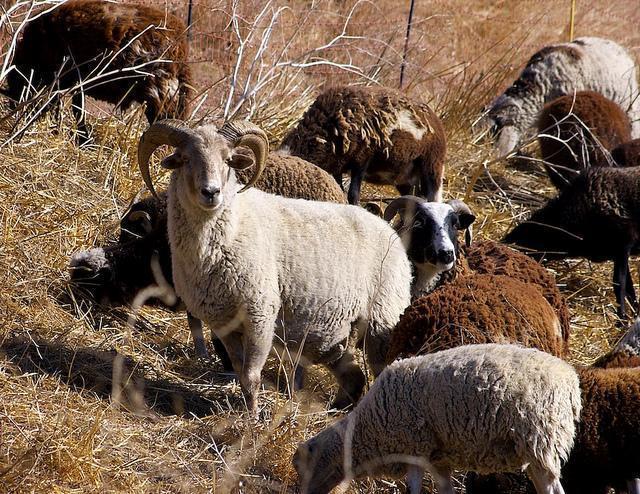Why are the sheep difference colors?
Indicate the correct response and explain using: 'Answer: answer
Rationale: rationale.'
Options: Breed, dirty, gender, spray-painted. Answer: breed.
Rationale: The sheep's breed is different. 